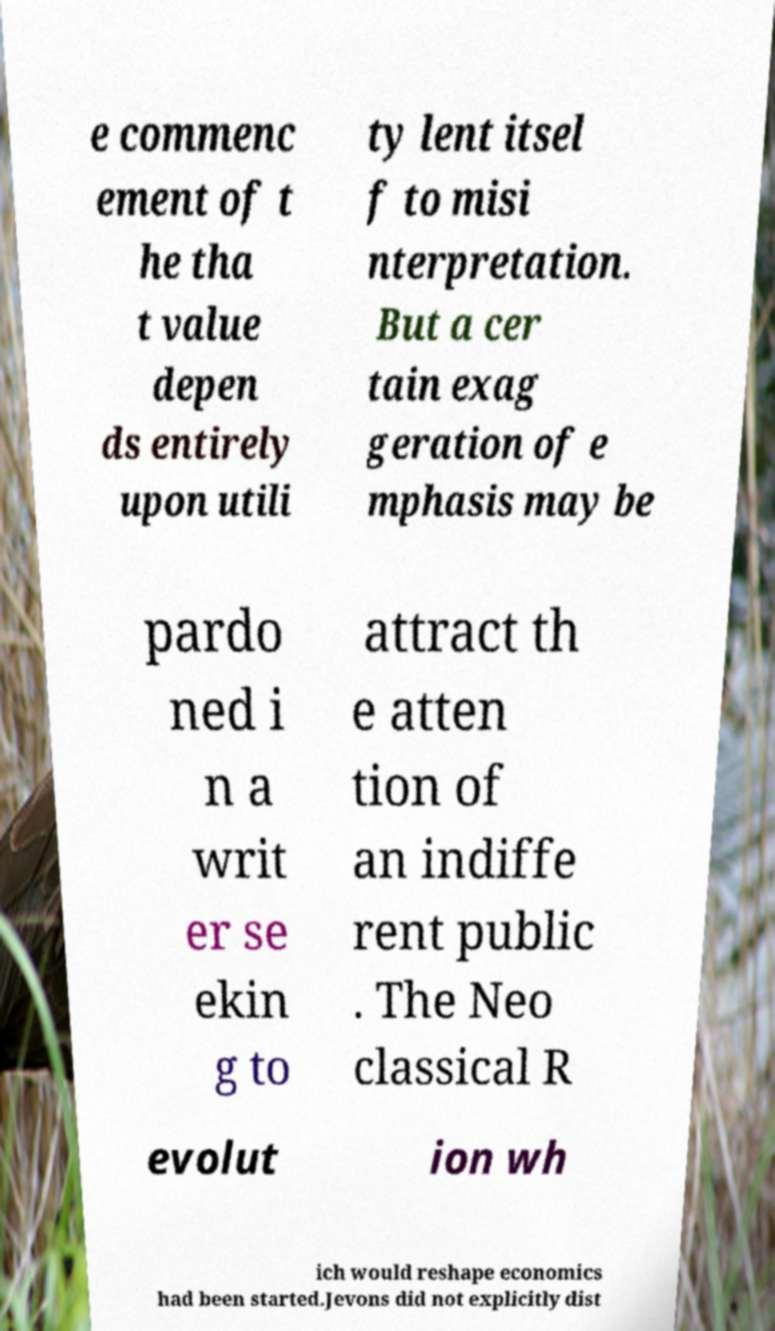Can you accurately transcribe the text from the provided image for me? e commenc ement of t he tha t value depen ds entirely upon utili ty lent itsel f to misi nterpretation. But a cer tain exag geration of e mphasis may be pardo ned i n a writ er se ekin g to attract th e atten tion of an indiffe rent public . The Neo classical R evolut ion wh ich would reshape economics had been started.Jevons did not explicitly dist 